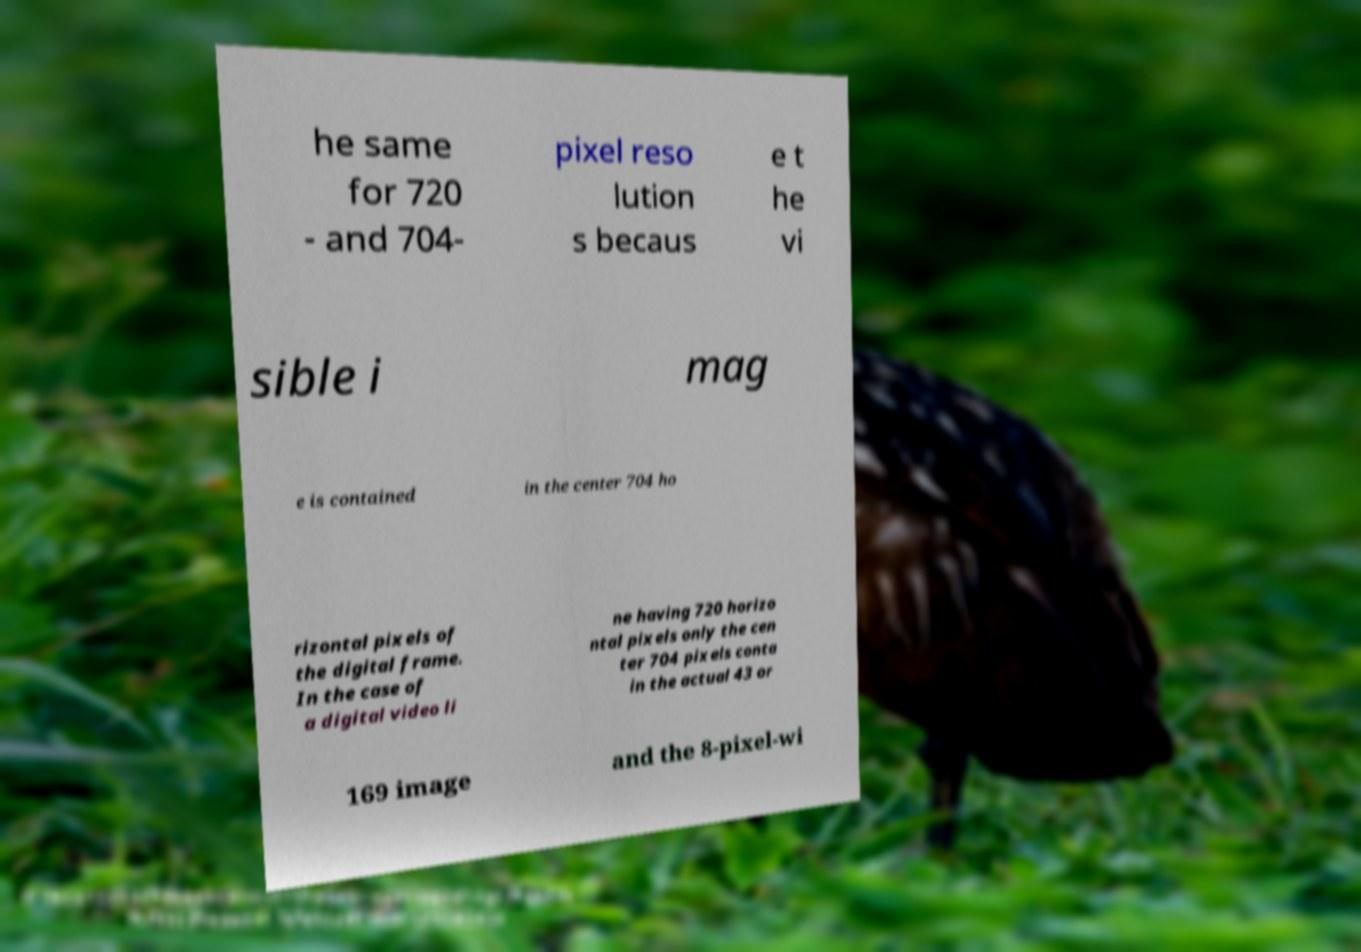There's text embedded in this image that I need extracted. Can you transcribe it verbatim? he same for 720 - and 704- pixel reso lution s becaus e t he vi sible i mag e is contained in the center 704 ho rizontal pixels of the digital frame. In the case of a digital video li ne having 720 horizo ntal pixels only the cen ter 704 pixels conta in the actual 43 or 169 image and the 8-pixel-wi 